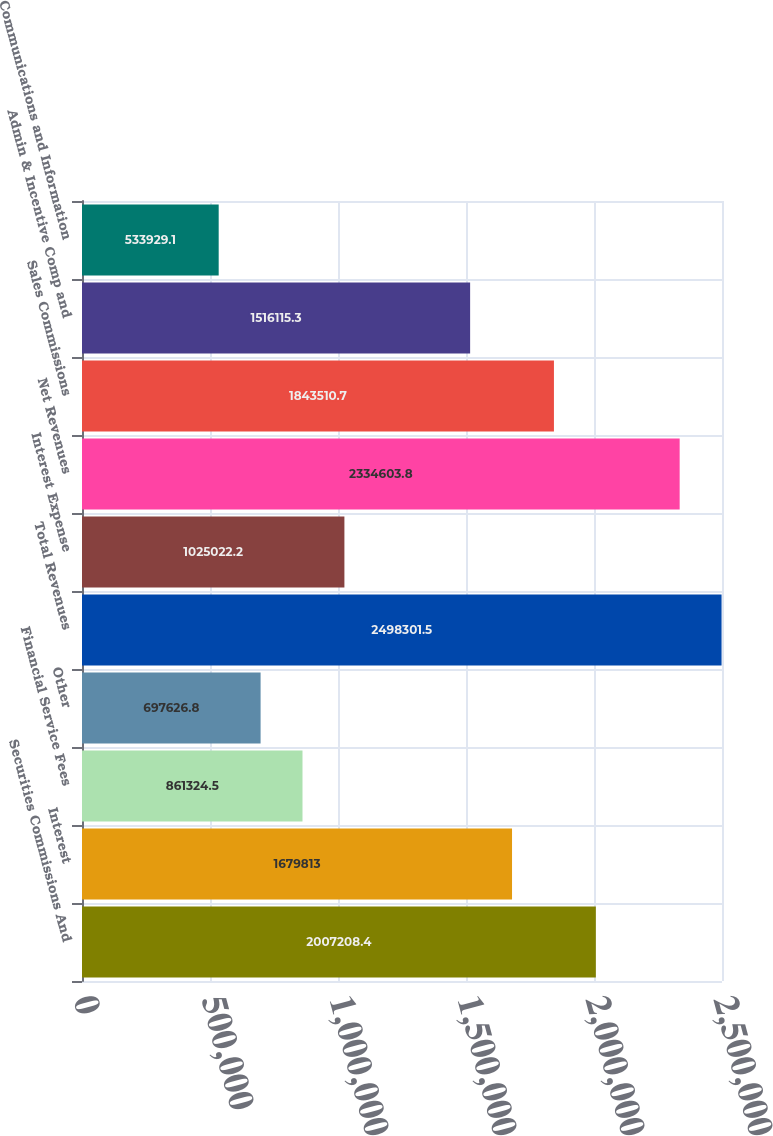<chart> <loc_0><loc_0><loc_500><loc_500><bar_chart><fcel>Securities Commissions And<fcel>Interest<fcel>Financial Service Fees<fcel>Other<fcel>Total Revenues<fcel>Interest Expense<fcel>Net Revenues<fcel>Sales Commissions<fcel>Admin & Incentive Comp and<fcel>Communications and Information<nl><fcel>2.00721e+06<fcel>1.67981e+06<fcel>861324<fcel>697627<fcel>2.4983e+06<fcel>1.02502e+06<fcel>2.3346e+06<fcel>1.84351e+06<fcel>1.51612e+06<fcel>533929<nl></chart> 